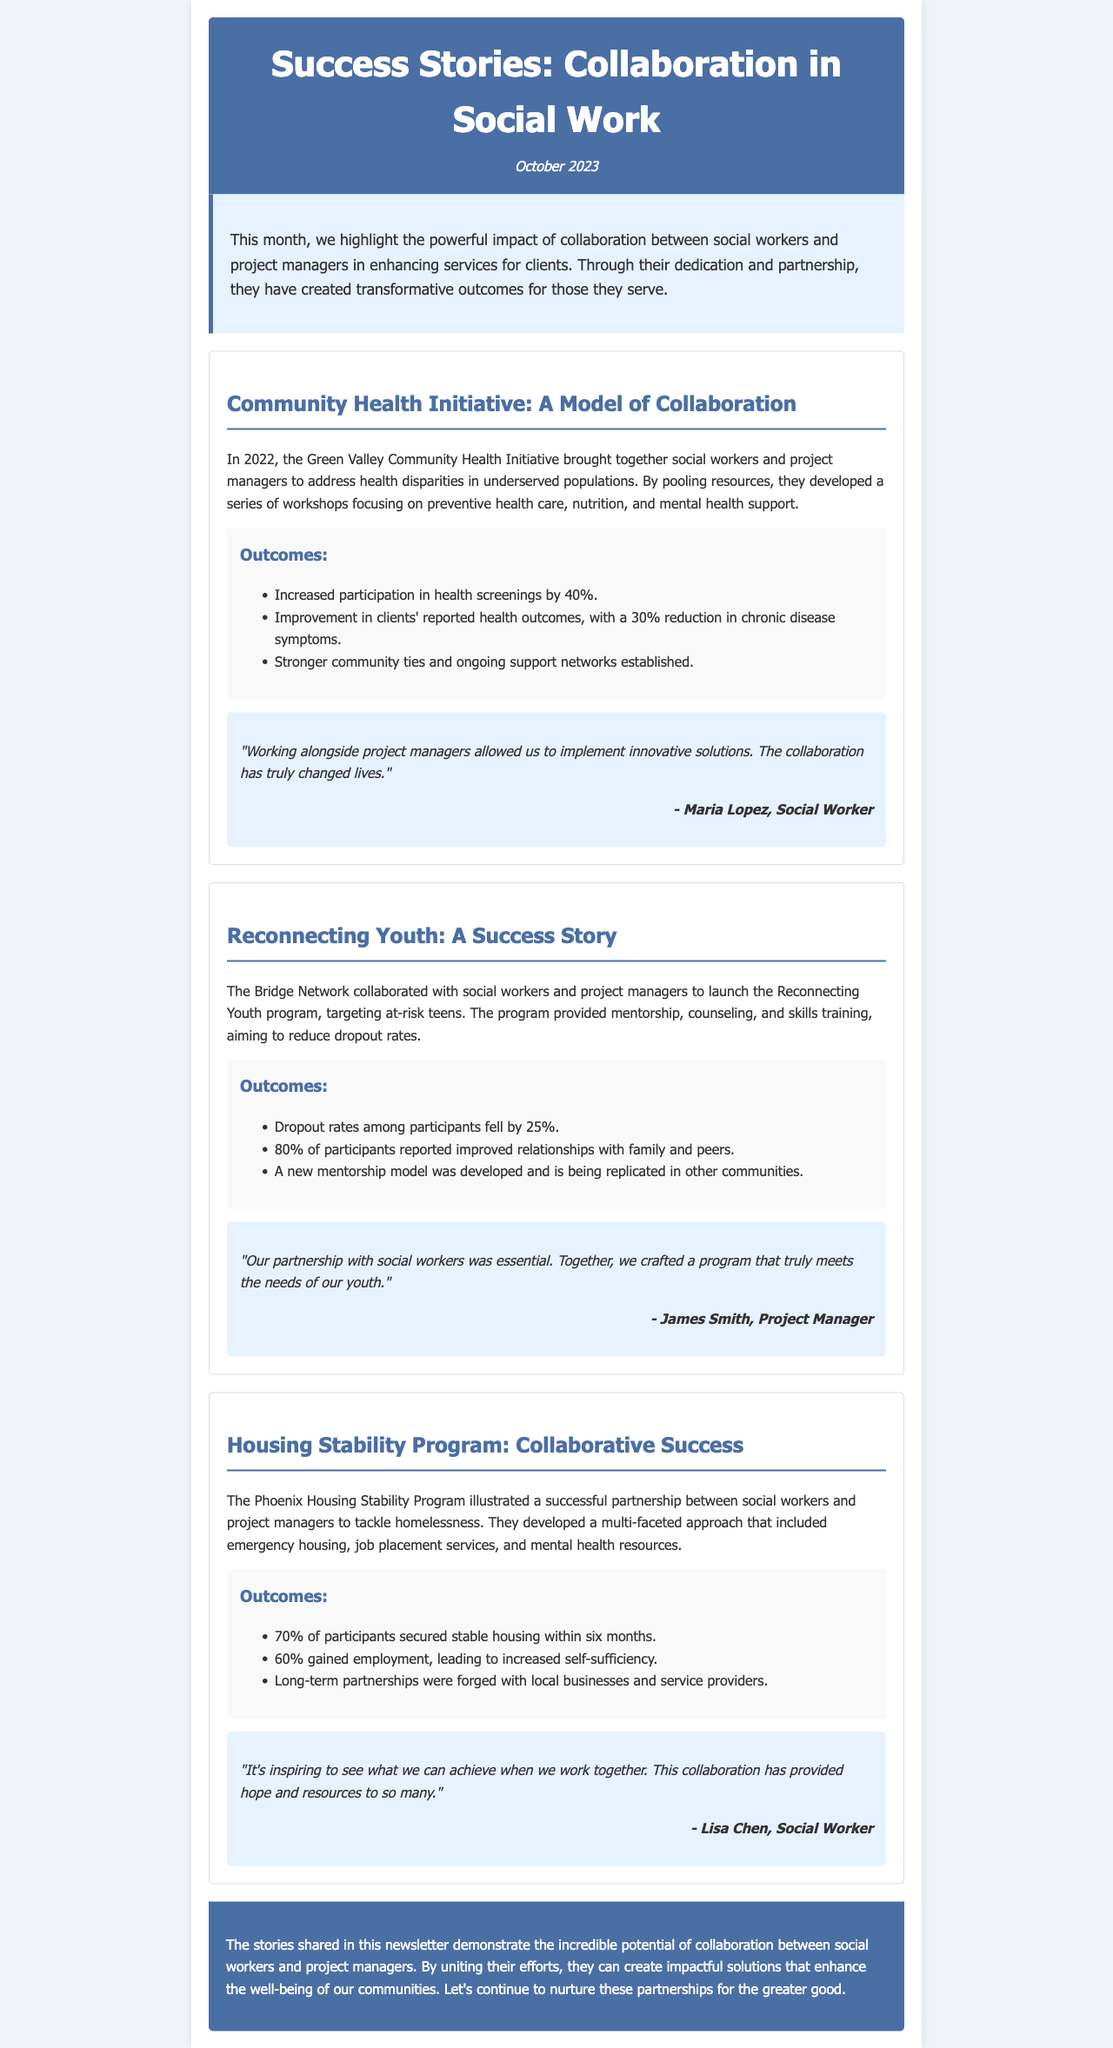What is the title of the newsletter? The title of the newsletter is stated in the header section, prominently displayed as the main title.
Answer: Success Stories: Collaboration in Social Work When was this newsletter published? The publication date is shown right under the title in the header section as a date reference.
Answer: October 2023 How much did participation in health screenings increase by in the Community Health Initiative? The increase in participation is mentioned in the outcomes section of the case study, providing a specific percentage.
Answer: 40% What percentage of participants in the Reconnecting Youth program reported improved relationships? The percentage is noted in the outcomes section of the case study, indicating a specific outcome related to youth relationships.
Answer: 80% What was the percentage of participants who secured stable housing within six months in the Housing Stability Program? This percentage is highlighted in the outcomes section of the program's case study.
Answer: 70% Who is the author of the testimonial in the Community Health Initiative case study? The author of the testimonial is mentioned directly below the quote in the testimonial section of the case study.
Answer: Maria Lopez What was the main goal of the Reconnecting Youth program? The goal is discussed in the introduction of the case study, summarizing the primary focus of the program.
Answer: Reduce dropout rates What type of program was illustrated in the Housing Stability Program case study? The type of program is specified in the introduction of the case study, clarifying its focus area.
Answer: Collaborative Success What color scheme is used for the header of the newsletter? The color scheme is described in the CSS styles applied to the header in the document structure.
Answer: Blue and white 